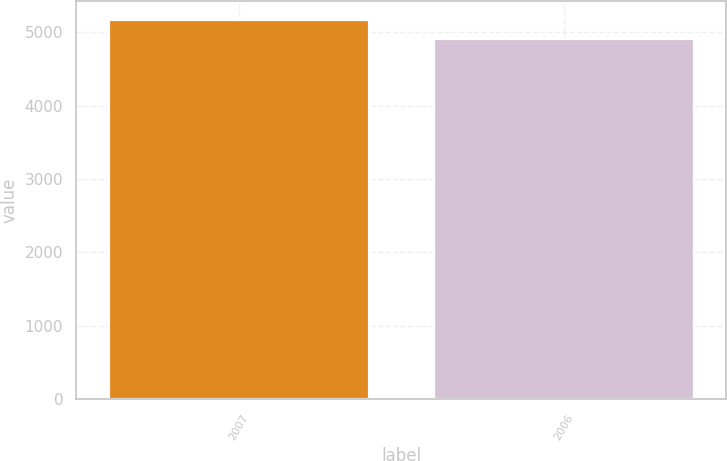Convert chart to OTSL. <chart><loc_0><loc_0><loc_500><loc_500><bar_chart><fcel>2007<fcel>2006<nl><fcel>5168<fcel>4912<nl></chart> 